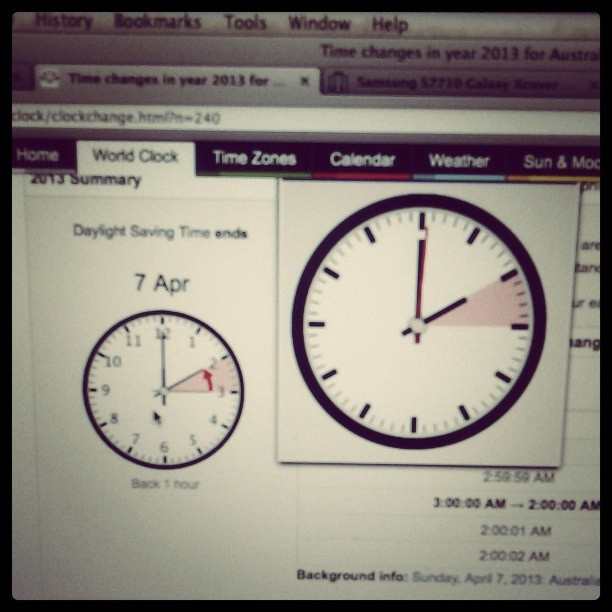Describe the objects in this image and their specific colors. I can see clock in black, beige, navy, and darkgray tones and clock in black, lightgray, darkgray, beige, and tan tones in this image. 